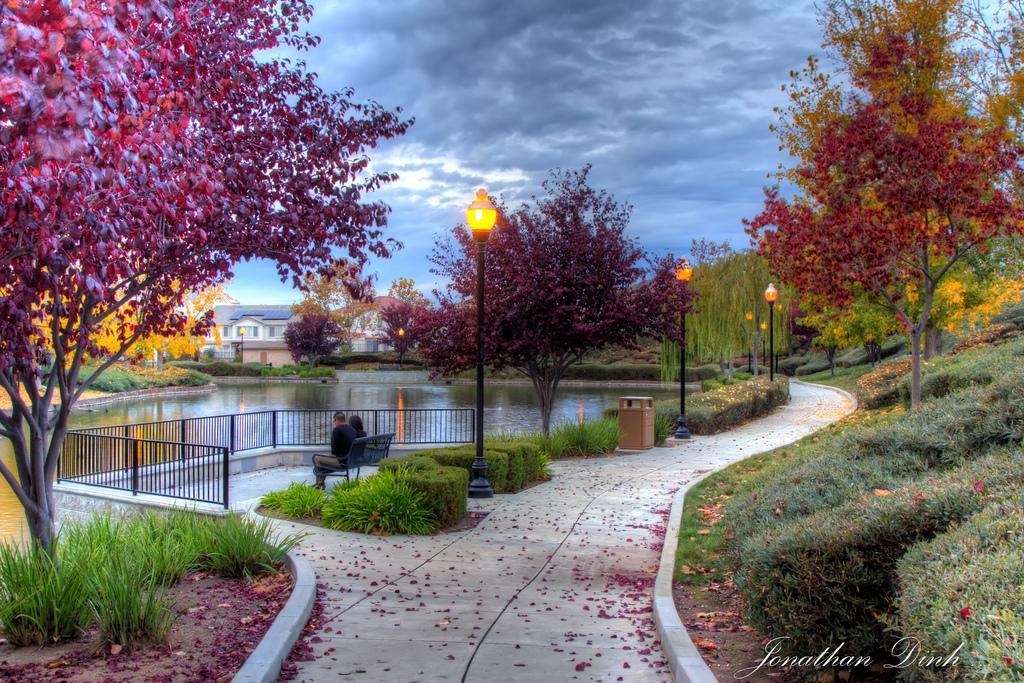Please provide a concise description of this image. On the bottom right, there is a watermark. On the right side, there are plants and trees on the ground. On the left side, there is a tree and plants on the ground, there is water, beside this water, there is a fence, beside this fence, there are two persons sitting on a bench, beside them, there are plants, lights attached to the poles and a tree on the ground, beside them, there is a road. In the background, there are buildings, there are trees and there are clouds in the sky. 